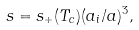Convert formula to latex. <formula><loc_0><loc_0><loc_500><loc_500>s = s _ { + } ( T _ { c } ) ( a _ { i } / a ) ^ { 3 } ,</formula> 